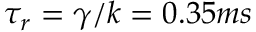<formula> <loc_0><loc_0><loc_500><loc_500>\tau _ { r } = \gamma / k = 0 . 3 5 m s</formula> 